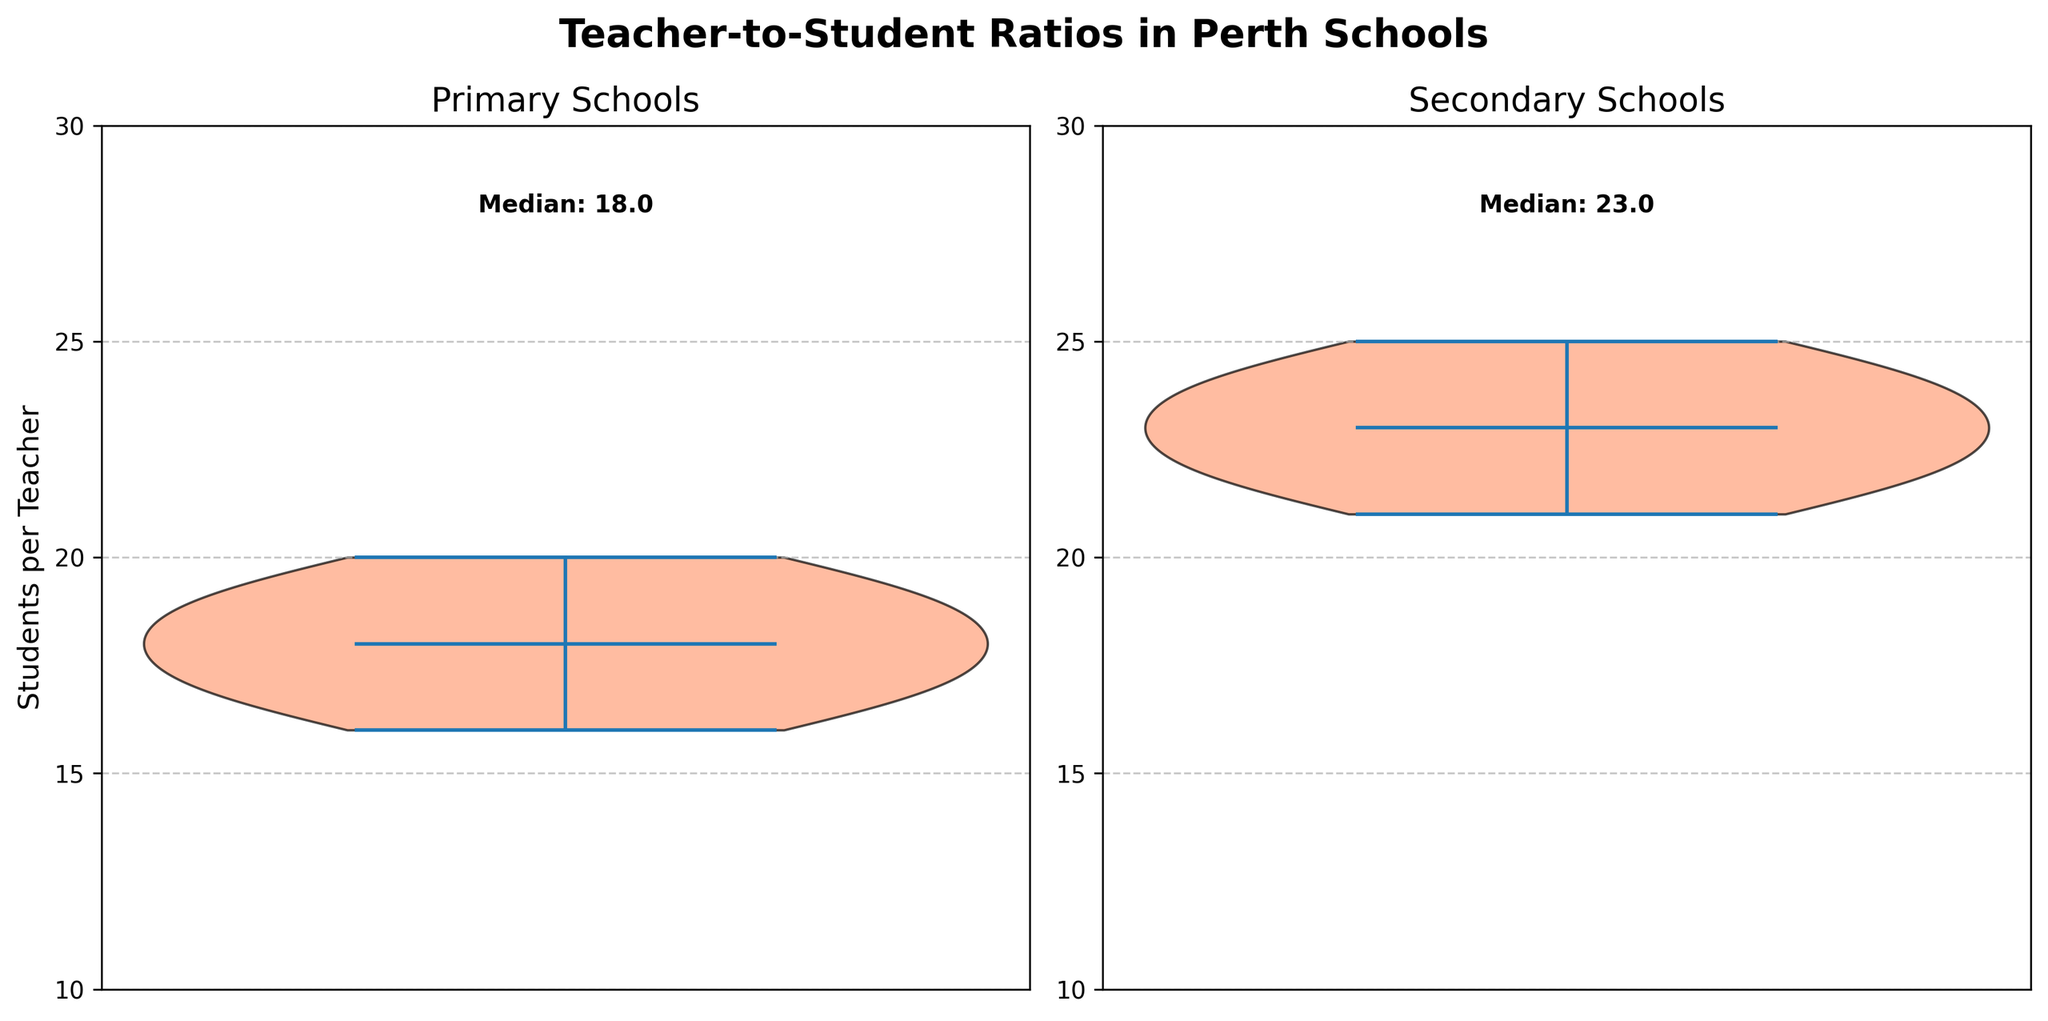What is the main title of the figure? The title is usually at the top center of the figure, indicating the general subject of the visualization. Here, it reads 'Teacher-to-Student Ratios in Perth Schools'.
Answer: Teacher-to-Student Ratios in Perth Schools What is the median teacher-to-student ratio in primary schools? The median value is explicitly labeled on the primary schools' violin plot as 'Median: 18.0'.
Answer: 18.0 What is the median teacher-to-student ratio in secondary schools? The median value is explicitly labeled on the secondary schools' violin plot as 'Median: 23.0'.
Answer: 23.0 How many levels of education are depicted in the plots? There are two subplots, each representing a different level of education, labeled as 'Primary Schools' and 'Secondary Schools'.
Answer: 2 Are the teacher-to-student ratios higher in primary or secondary schools? By comparing the median values annotated on the plots ('Median: 18.0' for Primary and 'Median: 23.0' for Secondary), we see that secondary schools have higher teacher-to-student ratios.
Answer: Secondary schools What is the range of the y-axis in the plots? Both plots have their y-axes labeled from 10 to 30.
Answer: 10 to 30 Which subplot has a wider distribution of teacher-to-student ratios? By observing the spread of the violin plots, you can see that the primary schools' ratios range from 16 to 20, while the secondary schools' ratios range from 21 to 25, both have a similar range of 4 units. The violin plots themselves appear similar in width.
Answer: Both are similar How are the teacher-to-student ratios visually represented in the plots? The teacher-to-student ratios are represented using violin plots, which show the distribution density of the ratios with an overlay of a central line indicating the median.
Answer: Violin plots What color is used for one half of the violins in each subplot? One half of the violins is colored in different shades. For instance, on close inspection, you notice salmon and pale green shades used in the plots.
Answer: Salmon and Pale Green How does the variability in teacher-to-student ratios compare between primary and secondary schools? Variability can be inferred from the shape and spread of the violins; both appear similar in their distribution range (4 units), indicating comparable variability.
Answer: Similar variability 